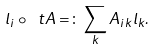<formula> <loc_0><loc_0><loc_500><loc_500>l _ { i } \circ \ t A = \colon \sum _ { k } A _ { i k } l _ { k } .</formula> 